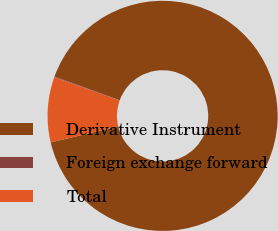Convert chart. <chart><loc_0><loc_0><loc_500><loc_500><pie_chart><fcel>Derivative Instrument<fcel>Foreign exchange forward<fcel>Total<nl><fcel>90.74%<fcel>0.1%<fcel>9.16%<nl></chart> 